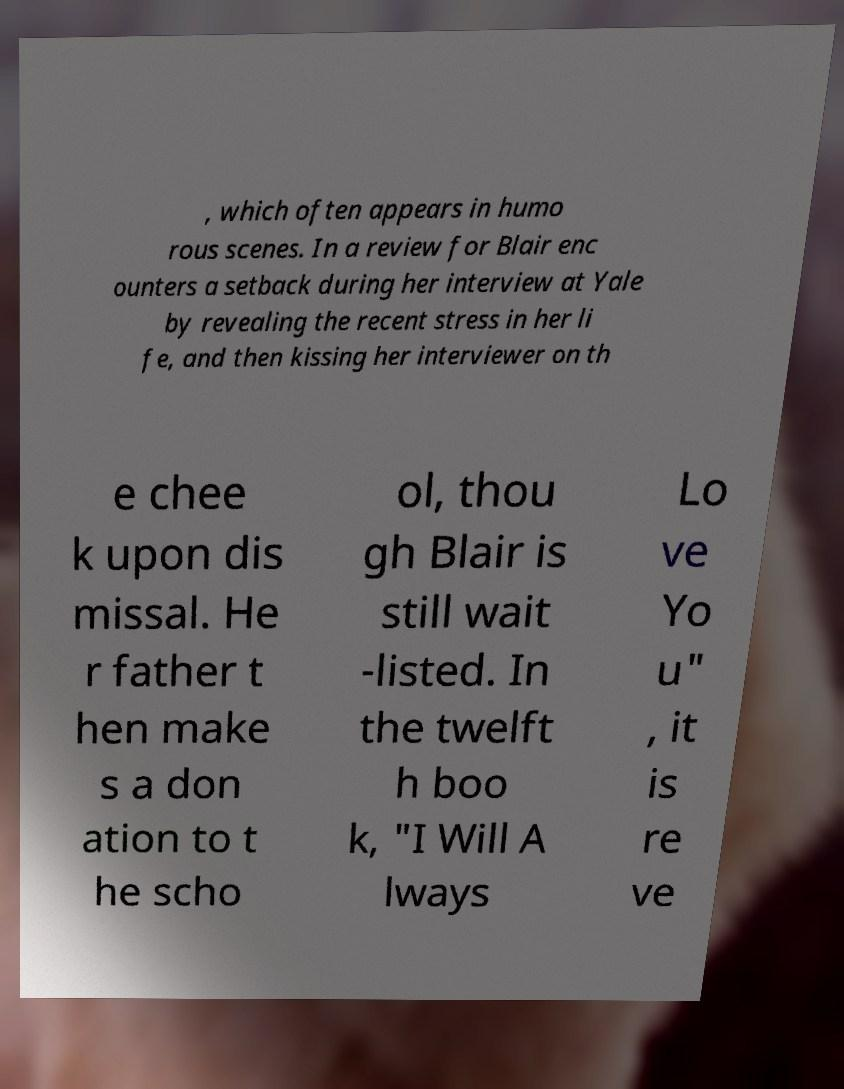Can you accurately transcribe the text from the provided image for me? , which often appears in humo rous scenes. In a review for Blair enc ounters a setback during her interview at Yale by revealing the recent stress in her li fe, and then kissing her interviewer on th e chee k upon dis missal. He r father t hen make s a don ation to t he scho ol, thou gh Blair is still wait -listed. In the twelft h boo k, "I Will A lways Lo ve Yo u" , it is re ve 